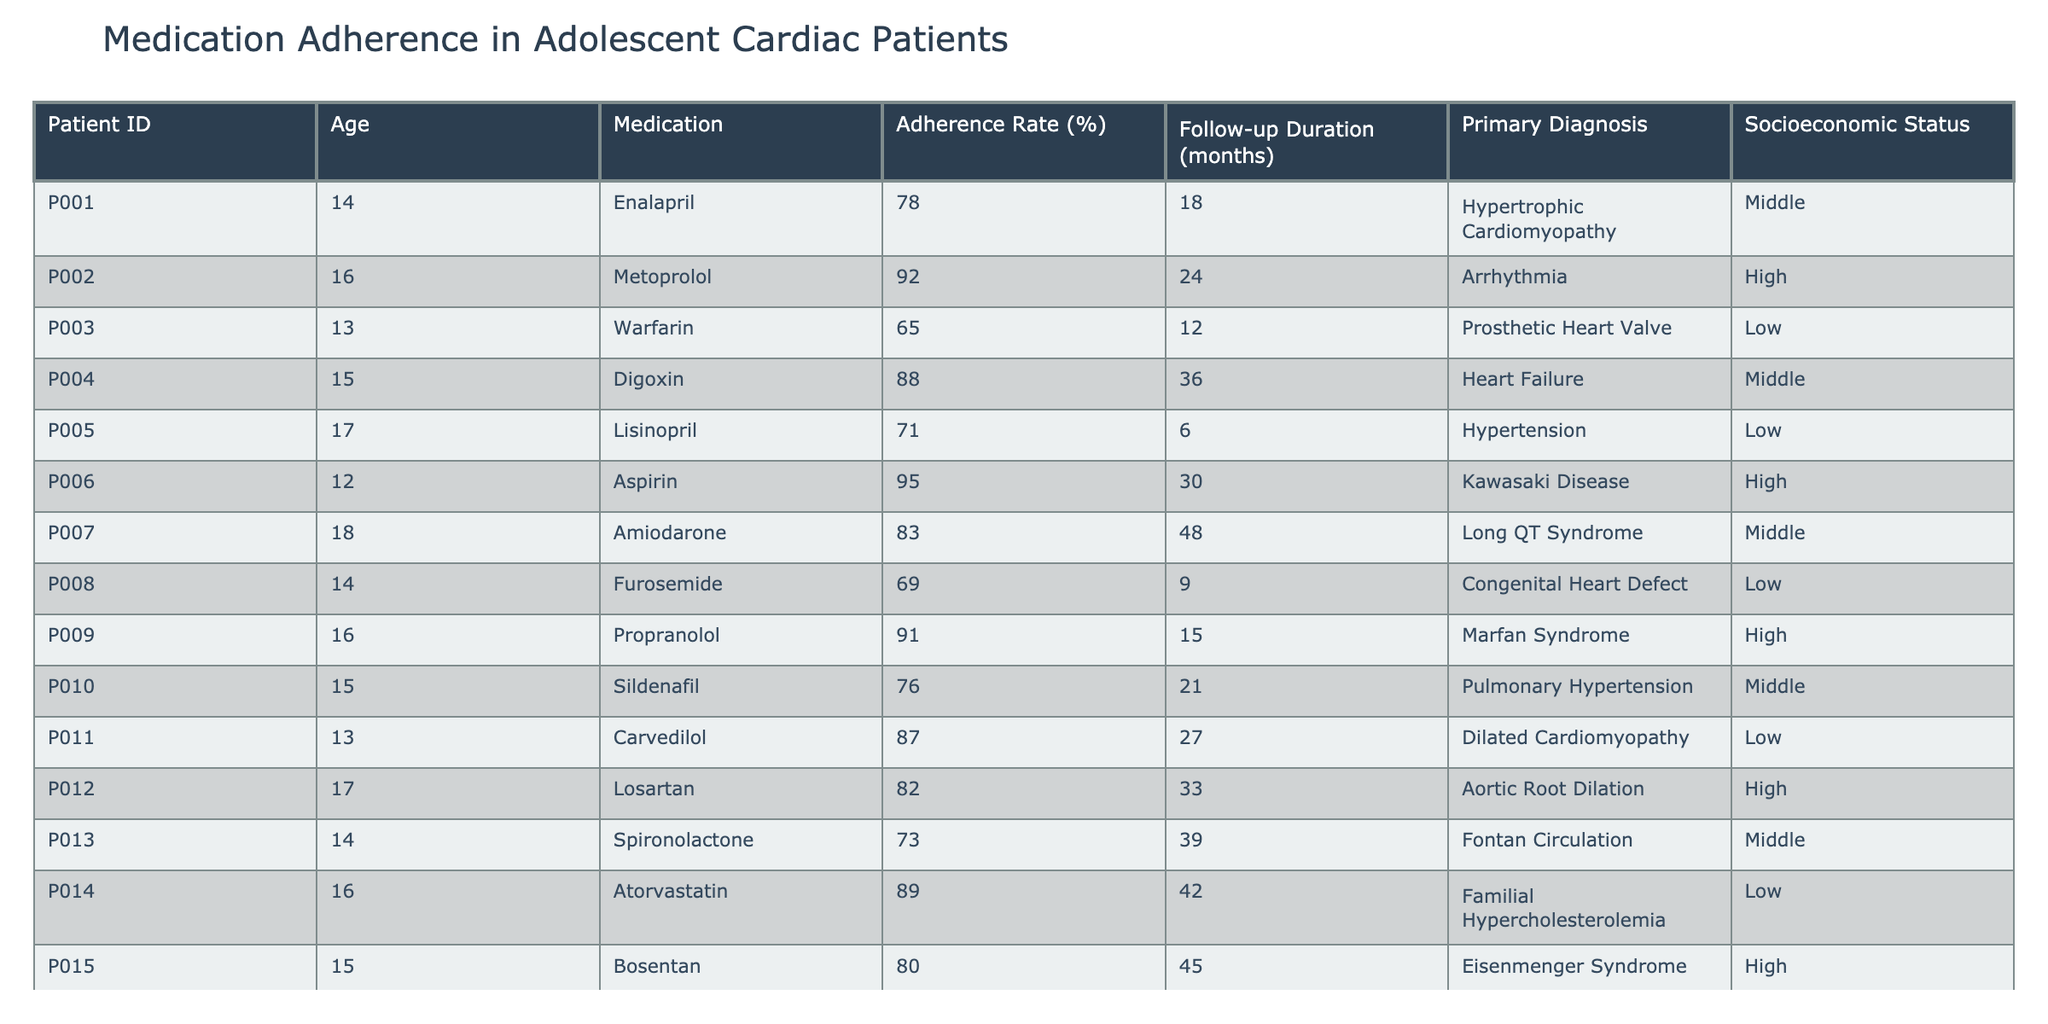What is the adherence rate for patient P006? Looking at the table, I find the row where Patient ID is P006, which has an adherence rate of 95%.
Answer: 95% Which medication has the highest adherence rate among the patients? By examining the adherence rates listed, I observe that the highest value is 95% for Aspirin (patient P006).
Answer: Aspirin How many patients have an adherence rate above 80%? I count the patients with adherence rates greater than 80%, which are: P002 (92%), P004 (88%), P009 (91%), P006 (95%), P012 (82%), P014 (89%), P015 (80%). This totals 7 patients.
Answer: 7 What is the average adherence rate of patients whose socioeconomic status is Low? The adherence rates of Low socioeconomic status patients (P003, P005, P008, P011, P014) are: 65%, 71%, 69%, 87%, and 89%. Summing these gives 65 + 71 + 69 + 87 + 89 = 381, and dividing by 5 gives an average of 76.2%.
Answer: 76.2% Is the adherence rate for patients with a primary diagnosis of Hypertension always lower than 80%? There is only one patient (P005) with Hypertension, who has an adherence rate of 71%, which is indeed lower than 80%. Therefore, the statement is true.
Answer: Yes Are there more patients from a high socioeconomic status with adherence rates above 80% than from a low socioeconomic status? Patients with a high socioeconomic status exceeding 80% in adherence are P002 (92%), P006 (95%), P009 (91%), and P012 (82%), totaling 4 patients. In low socioeconomic status, patients above 80% are P011 (87%) and P014 (89%), totaling 2 patients. Thus, high socioeconomic status has more patients with adherence above 80%.
Answer: Yes What is the adherence rate difference between the highest and lowest adherence rates? The highest adherence rate is 95% (Aspirin) and the lowest is 65% (Warfarin). The difference is 95 - 65 = 30%.
Answer: 30% 